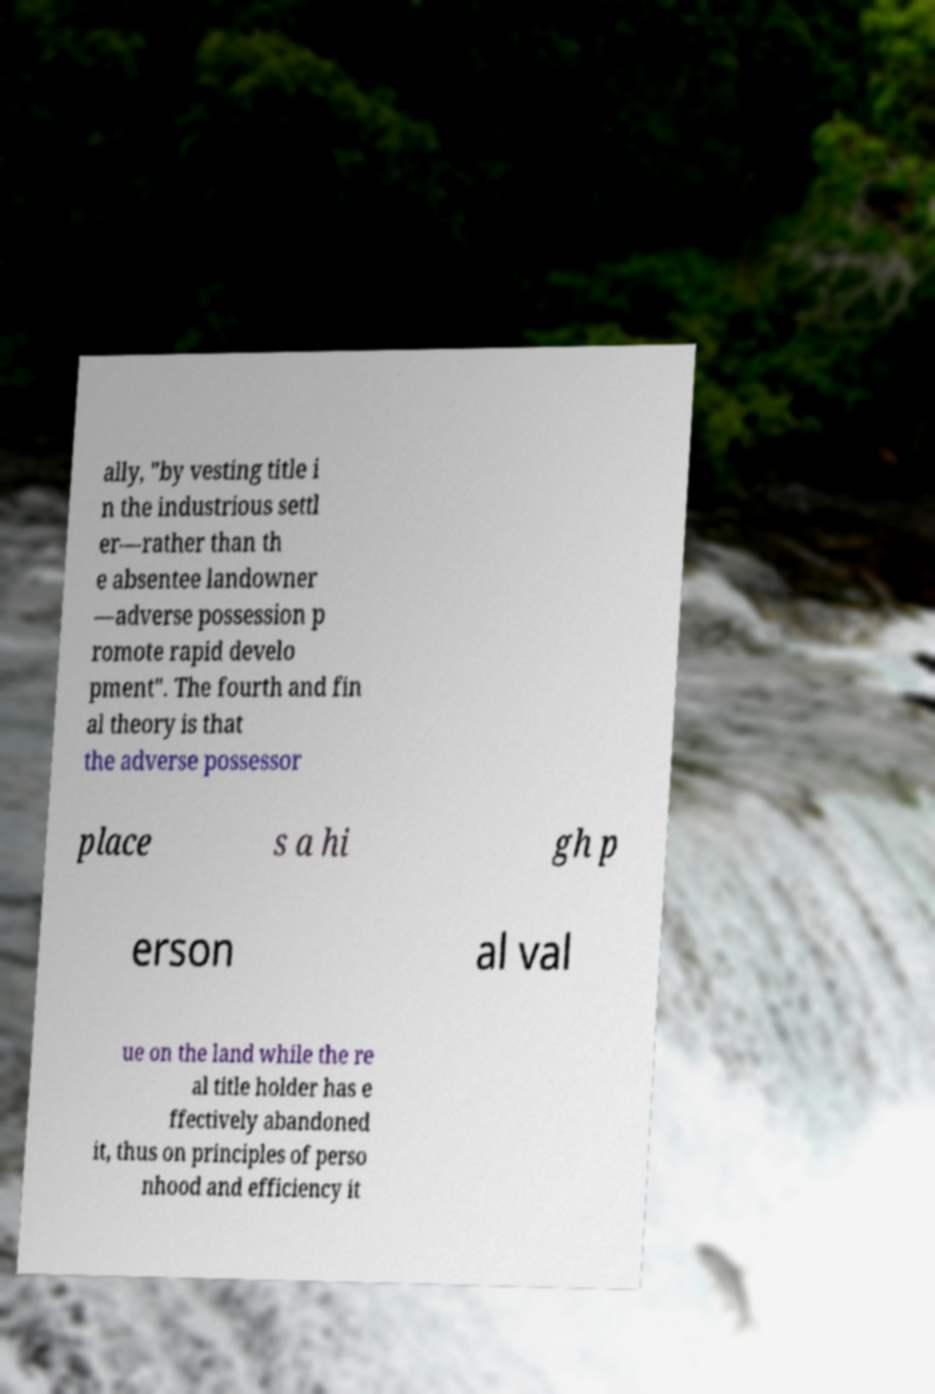For documentation purposes, I need the text within this image transcribed. Could you provide that? ally, "by vesting title i n the industrious settl er—rather than th e absentee landowner —adverse possession p romote rapid develo pment". The fourth and fin al theory is that the adverse possessor place s a hi gh p erson al val ue on the land while the re al title holder has e ffectively abandoned it, thus on principles of perso nhood and efficiency it 